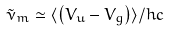Convert formula to latex. <formula><loc_0><loc_0><loc_500><loc_500>\tilde { \nu } _ { m } \simeq \langle \left ( V _ { u } - V _ { g } \right ) \rangle / h c</formula> 